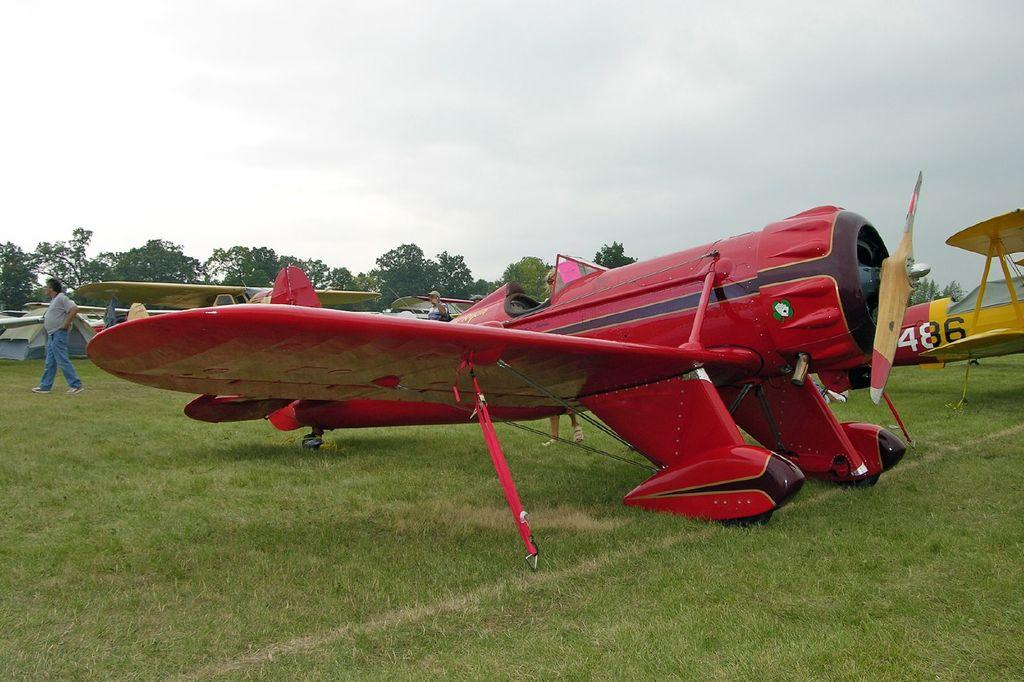<image>
Present a compact description of the photo's key features. A yellow plane numbered 486 is behind a red plane. 